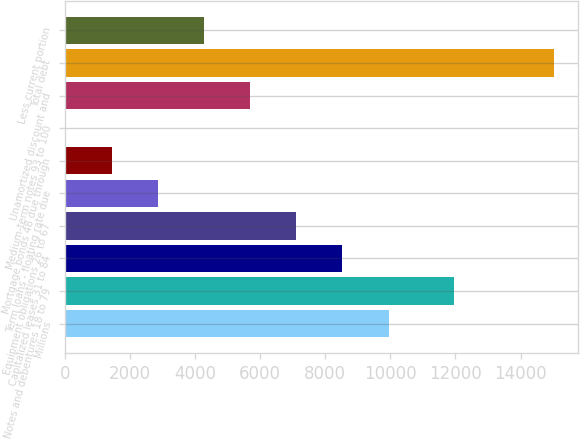Convert chart. <chart><loc_0><loc_0><loc_500><loc_500><bar_chart><fcel>Millions<fcel>Notes and debentures 18 to 79<fcel>Capitalized leases 31 to 84<fcel>Equipment obligations 26 to 67<fcel>Term loans - floating rate due<fcel>Mortgage bonds 48 due through<fcel>Medium-term notes 93 to 100<fcel>Unamortized discount and<fcel>Total debt<fcel>Less current portion<nl><fcel>9947.6<fcel>11964<fcel>8529.8<fcel>7112<fcel>2858.6<fcel>1440.8<fcel>23<fcel>5694.2<fcel>15024.8<fcel>4276.4<nl></chart> 